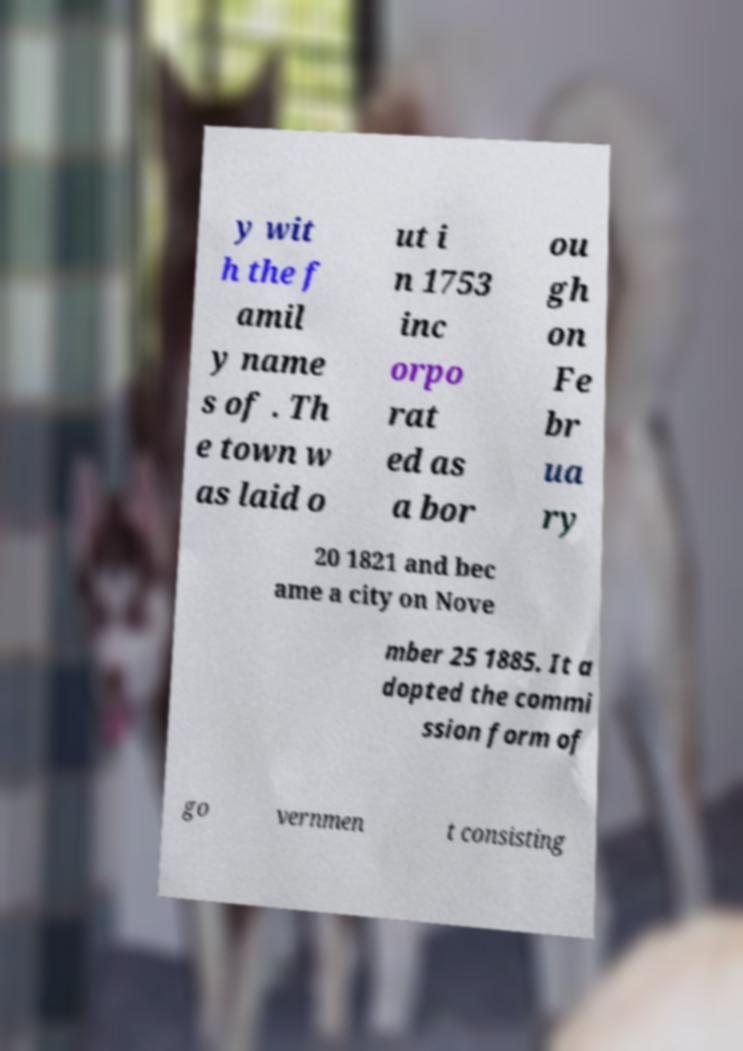Can you accurately transcribe the text from the provided image for me? y wit h the f amil y name s of . Th e town w as laid o ut i n 1753 inc orpo rat ed as a bor ou gh on Fe br ua ry 20 1821 and bec ame a city on Nove mber 25 1885. It a dopted the commi ssion form of go vernmen t consisting 